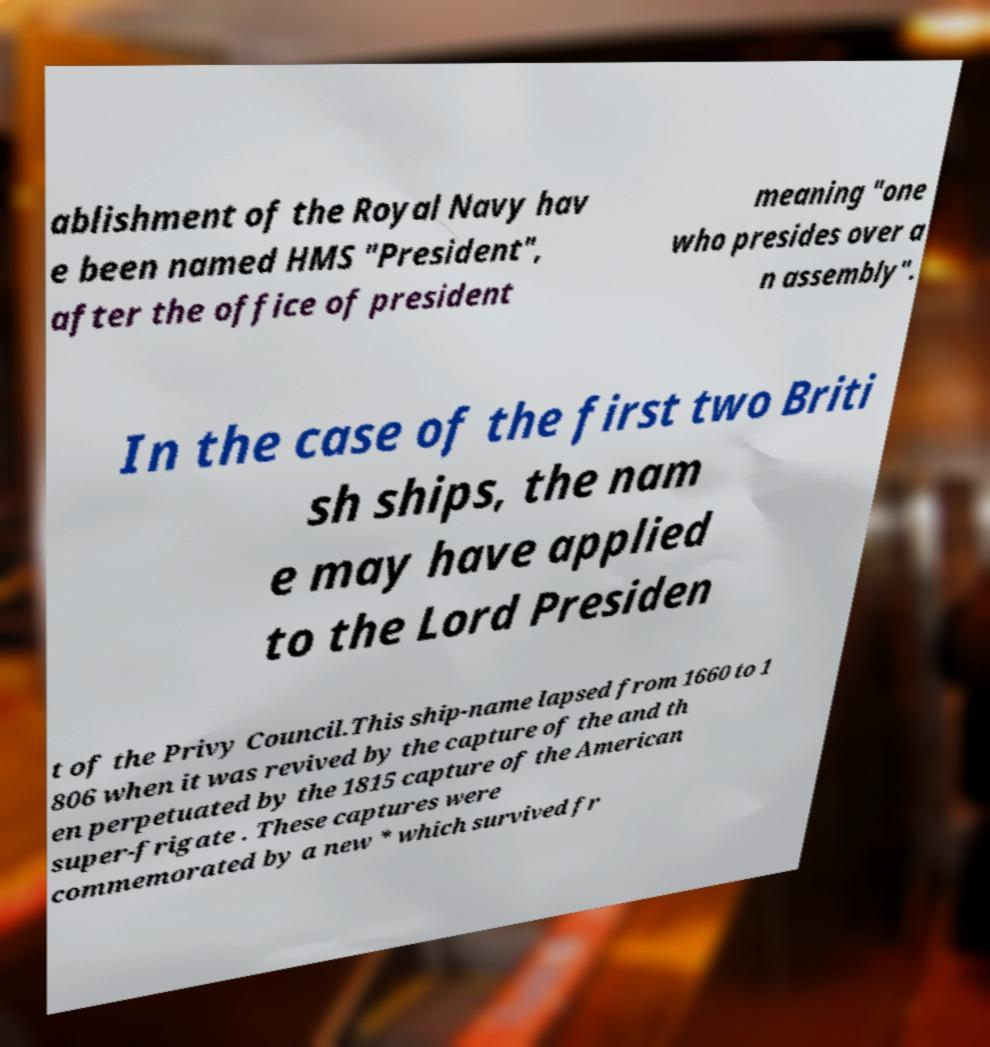Could you extract and type out the text from this image? ablishment of the Royal Navy hav e been named HMS "President", after the office of president meaning "one who presides over a n assembly". In the case of the first two Briti sh ships, the nam e may have applied to the Lord Presiden t of the Privy Council.This ship-name lapsed from 1660 to 1 806 when it was revived by the capture of the and th en perpetuated by the 1815 capture of the American super-frigate . These captures were commemorated by a new * which survived fr 